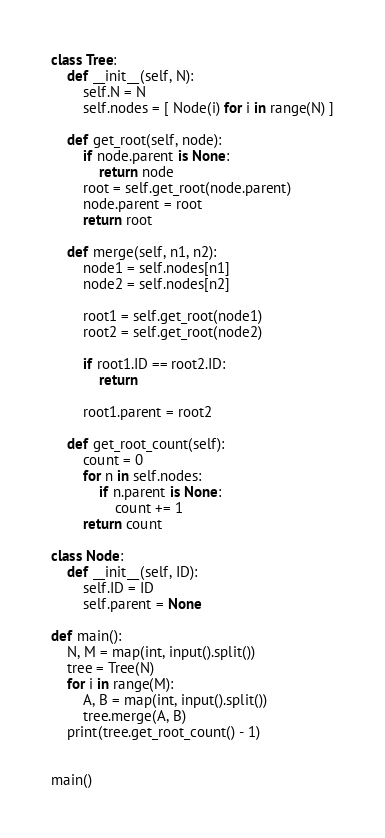Convert code to text. <code><loc_0><loc_0><loc_500><loc_500><_Python_>class Tree:
    def __init__(self, N):
        self.N = N
        self.nodes = [ Node(i) for i in range(N) ]

    def get_root(self, node):
        if node.parent is None:
            return node
        root = self.get_root(node.parent)
        node.parent = root
        return root

    def merge(self, n1, n2):
        node1 = self.nodes[n1]
        node2 = self.nodes[n2]

        root1 = self.get_root(node1)
        root2 = self.get_root(node2)

        if root1.ID == root2.ID:
            return

        root1.parent = root2

    def get_root_count(self):
        count = 0
        for n in self.nodes:
            if n.parent is None:
                count += 1
        return count

class Node:
    def __init__(self, ID):
        self.ID = ID
        self.parent = None

def main():
    N, M = map(int, input().split())
    tree = Tree(N)
    for i in range(M):
        A, B = map(int, input().split())
        tree.merge(A, B)
    print(tree.get_root_count() - 1)


main()
</code> 